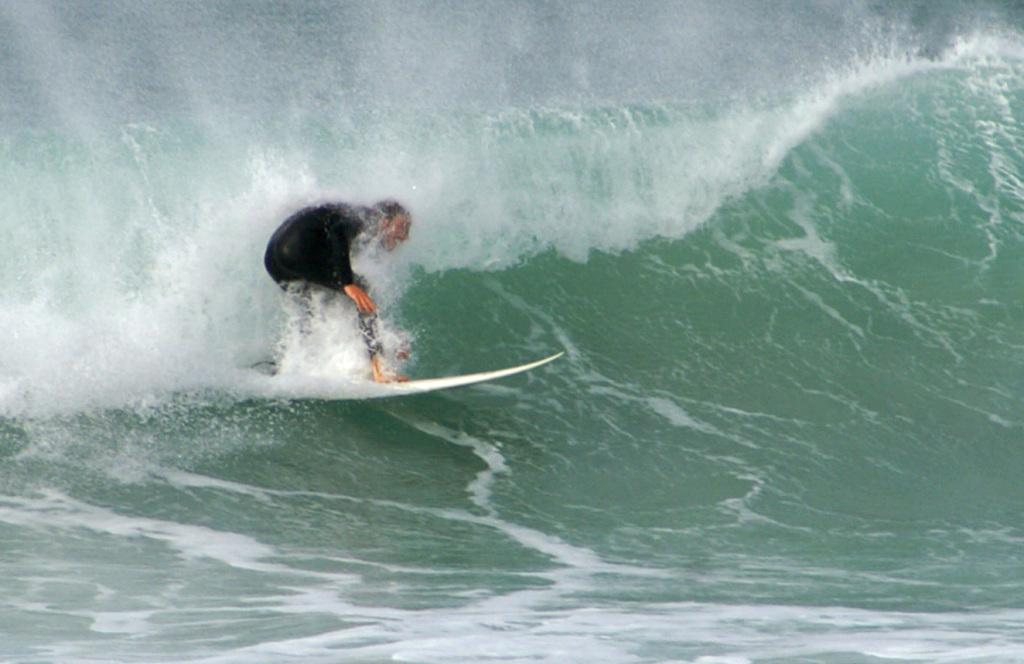What is the person in the image doing? The person is surfing. What tool or equipment is the person using to surf? The person is using a surfboard. Where is the surfing taking place? The surfing is taking place on water. What can be seen in the image that might be related to the surfing activity? There is a wave visible in the image. What type of vest is the person wearing while surfing in the image? There is no vest visible on the person in the image. What question is the person asking while surfing in the image? The image does not show the person asking any questions while surfing. 